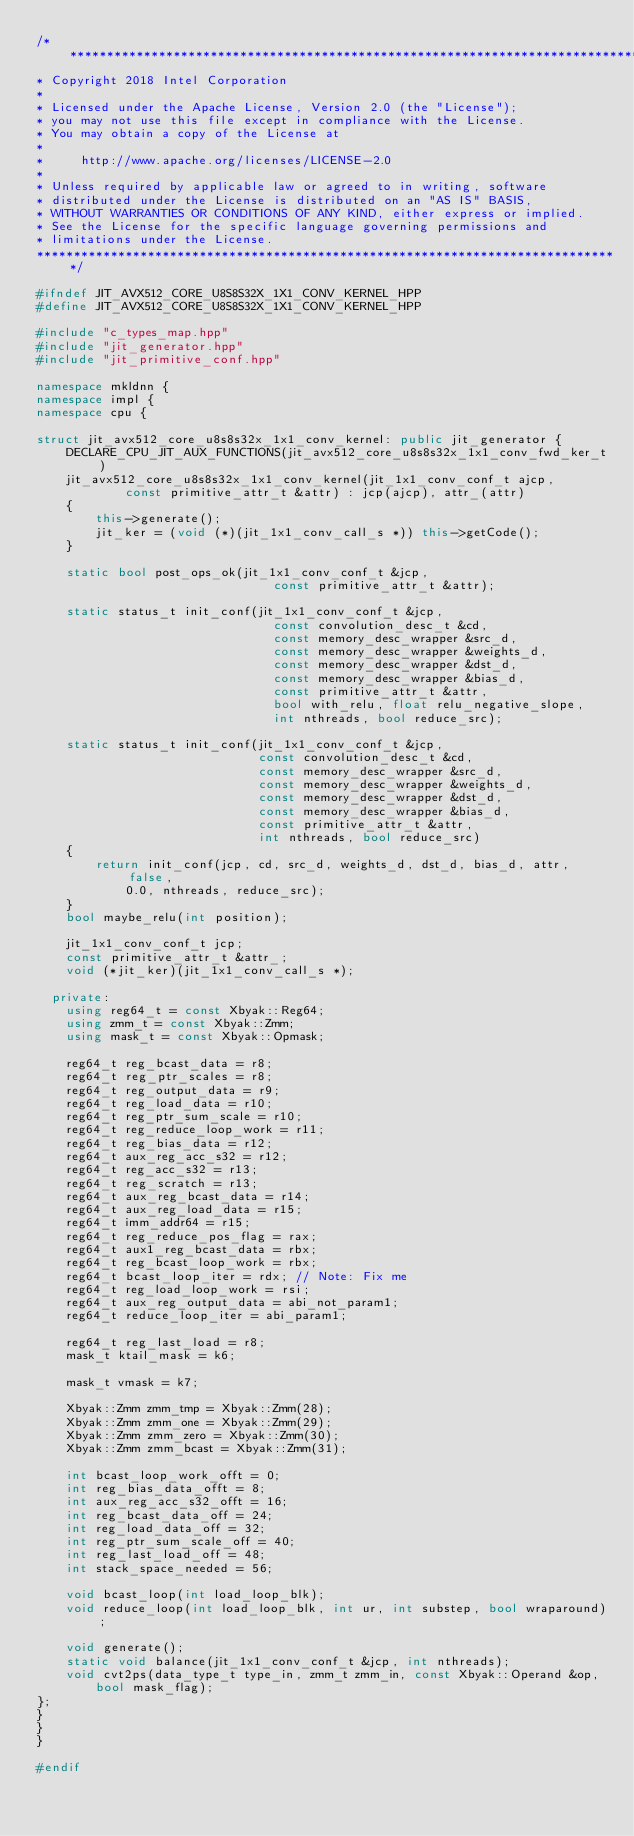Convert code to text. <code><loc_0><loc_0><loc_500><loc_500><_C++_>/*******************************************************************************
* Copyright 2018 Intel Corporation
*
* Licensed under the Apache License, Version 2.0 (the "License");
* you may not use this file except in compliance with the License.
* You may obtain a copy of the License at
*
*     http://www.apache.org/licenses/LICENSE-2.0
*
* Unless required by applicable law or agreed to in writing, software
* distributed under the License is distributed on an "AS IS" BASIS,
* WITHOUT WARRANTIES OR CONDITIONS OF ANY KIND, either express or implied.
* See the License for the specific language governing permissions and
* limitations under the License.
*******************************************************************************/

#ifndef JIT_AVX512_CORE_U8S8S32X_1X1_CONV_KERNEL_HPP
#define JIT_AVX512_CORE_U8S8S32X_1X1_CONV_KERNEL_HPP

#include "c_types_map.hpp"
#include "jit_generator.hpp"
#include "jit_primitive_conf.hpp"

namespace mkldnn {
namespace impl {
namespace cpu {

struct jit_avx512_core_u8s8s32x_1x1_conv_kernel: public jit_generator {
    DECLARE_CPU_JIT_AUX_FUNCTIONS(jit_avx512_core_u8s8s32x_1x1_conv_fwd_ker_t)
    jit_avx512_core_u8s8s32x_1x1_conv_kernel(jit_1x1_conv_conf_t ajcp,
            const primitive_attr_t &attr) : jcp(ajcp), attr_(attr)
    {
        this->generate();
        jit_ker = (void (*)(jit_1x1_conv_call_s *)) this->getCode();
    }

    static bool post_ops_ok(jit_1x1_conv_conf_t &jcp,
                                const primitive_attr_t &attr);

    static status_t init_conf(jit_1x1_conv_conf_t &jcp,
                                const convolution_desc_t &cd,
                                const memory_desc_wrapper &src_d,
                                const memory_desc_wrapper &weights_d,
                                const memory_desc_wrapper &dst_d,
                                const memory_desc_wrapper &bias_d,
                                const primitive_attr_t &attr,
                                bool with_relu, float relu_negative_slope,
                                int nthreads, bool reduce_src);

    static status_t init_conf(jit_1x1_conv_conf_t &jcp,
                              const convolution_desc_t &cd,
                              const memory_desc_wrapper &src_d,
                              const memory_desc_wrapper &weights_d,
                              const memory_desc_wrapper &dst_d,
                              const memory_desc_wrapper &bias_d,
                              const primitive_attr_t &attr,
                              int nthreads, bool reduce_src)
    {
        return init_conf(jcp, cd, src_d, weights_d, dst_d, bias_d, attr, false,
            0.0, nthreads, reduce_src);
    }
    bool maybe_relu(int position);

    jit_1x1_conv_conf_t jcp;
    const primitive_attr_t &attr_;
    void (*jit_ker)(jit_1x1_conv_call_s *);

  private:
    using reg64_t = const Xbyak::Reg64;
    using zmm_t = const Xbyak::Zmm;
    using mask_t = const Xbyak::Opmask;

    reg64_t reg_bcast_data = r8;
    reg64_t reg_ptr_scales = r8;
    reg64_t reg_output_data = r9;
    reg64_t reg_load_data = r10;
    reg64_t reg_ptr_sum_scale = r10;
    reg64_t reg_reduce_loop_work = r11;
    reg64_t reg_bias_data = r12;
    reg64_t aux_reg_acc_s32 = r12;
    reg64_t reg_acc_s32 = r13;
    reg64_t reg_scratch = r13;
    reg64_t aux_reg_bcast_data = r14;
    reg64_t aux_reg_load_data = r15;
    reg64_t imm_addr64 = r15;
    reg64_t reg_reduce_pos_flag = rax;
    reg64_t aux1_reg_bcast_data = rbx;
    reg64_t reg_bcast_loop_work = rbx;
    reg64_t bcast_loop_iter = rdx; // Note: Fix me
    reg64_t reg_load_loop_work = rsi;
    reg64_t aux_reg_output_data = abi_not_param1;
    reg64_t reduce_loop_iter = abi_param1;

    reg64_t reg_last_load = r8;
    mask_t ktail_mask = k6;

    mask_t vmask = k7;

    Xbyak::Zmm zmm_tmp = Xbyak::Zmm(28);
    Xbyak::Zmm zmm_one = Xbyak::Zmm(29);
    Xbyak::Zmm zmm_zero = Xbyak::Zmm(30);
    Xbyak::Zmm zmm_bcast = Xbyak::Zmm(31);

    int bcast_loop_work_offt = 0;
    int reg_bias_data_offt = 8;
    int aux_reg_acc_s32_offt = 16;
    int reg_bcast_data_off = 24;
    int reg_load_data_off = 32;
    int reg_ptr_sum_scale_off = 40;
    int reg_last_load_off = 48;
    int stack_space_needed = 56;

    void bcast_loop(int load_loop_blk);
    void reduce_loop(int load_loop_blk, int ur, int substep, bool wraparound);

    void generate();
    static void balance(jit_1x1_conv_conf_t &jcp, int nthreads);
    void cvt2ps(data_type_t type_in, zmm_t zmm_in, const Xbyak::Operand &op,
        bool mask_flag);
};
}
}
}

#endif
</code> 